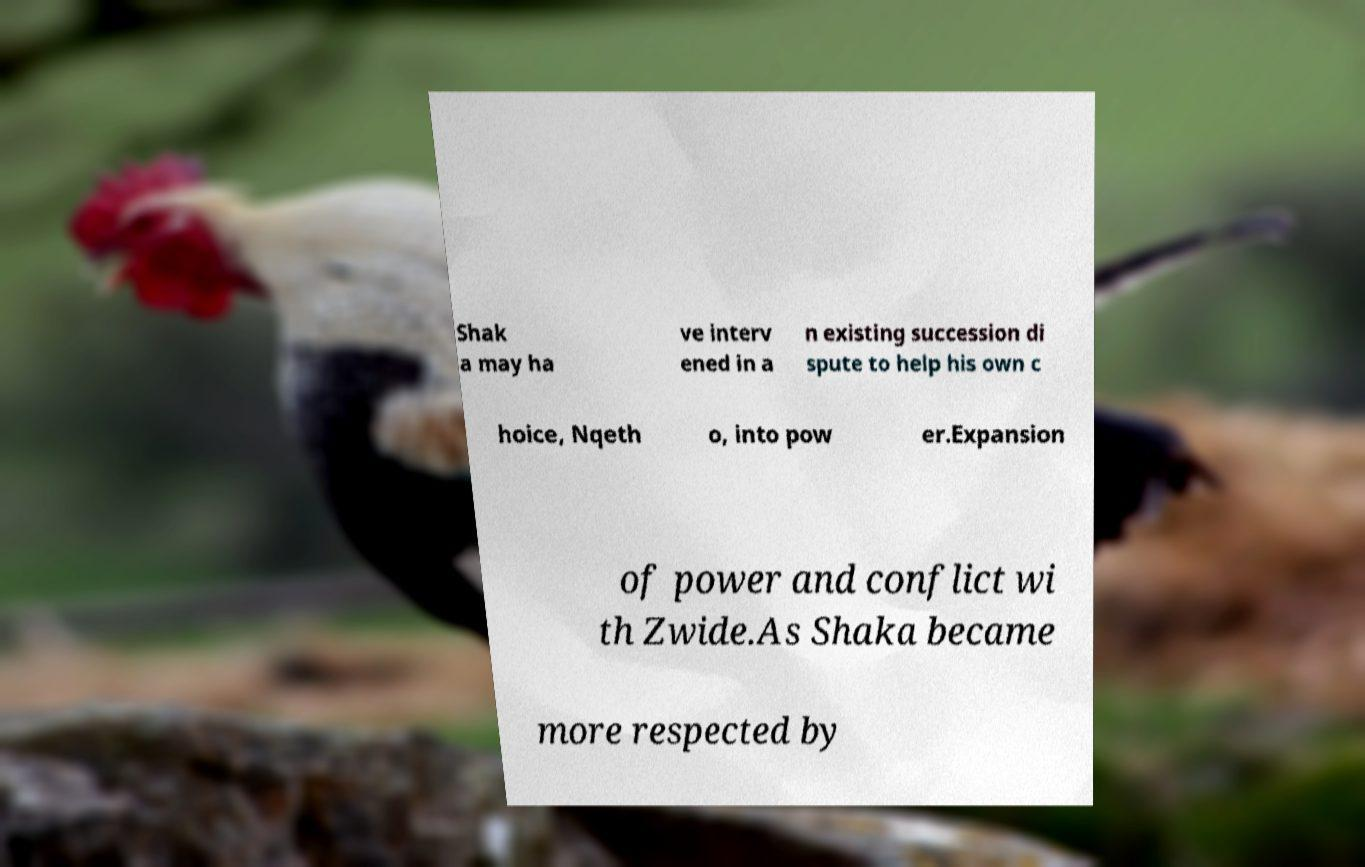What messages or text are displayed in this image? I need them in a readable, typed format. Shak a may ha ve interv ened in a n existing succession di spute to help his own c hoice, Nqeth o, into pow er.Expansion of power and conflict wi th Zwide.As Shaka became more respected by 